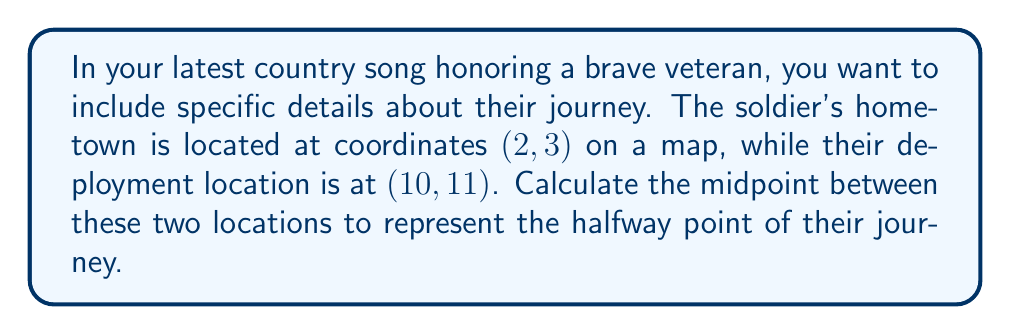Give your solution to this math problem. To find the midpoint between two points, we use the midpoint formula:

$$ \text{Midpoint} = \left(\frac{x_1 + x_2}{2}, \frac{y_1 + y_2}{2}\right) $$

Where $(x_1, y_1)$ is the first point and $(x_2, y_2)$ is the second point.

In this case:
- Hometown: $(x_1, y_1) = (2, 3)$
- Deployment location: $(x_2, y_2) = (10, 11)$

Let's calculate the x-coordinate of the midpoint:

$$ x_{\text{midpoint}} = \frac{x_1 + x_2}{2} = \frac{2 + 10}{2} = \frac{12}{2} = 6 $$

Now, let's calculate the y-coordinate of the midpoint:

$$ y_{\text{midpoint}} = \frac{y_1 + y_2}{2} = \frac{3 + 11}{2} = \frac{14}{2} = 7 $$

Therefore, the midpoint coordinates are (6, 7).
Answer: The midpoint between the soldier's hometown and deployment location is (6, 7). 